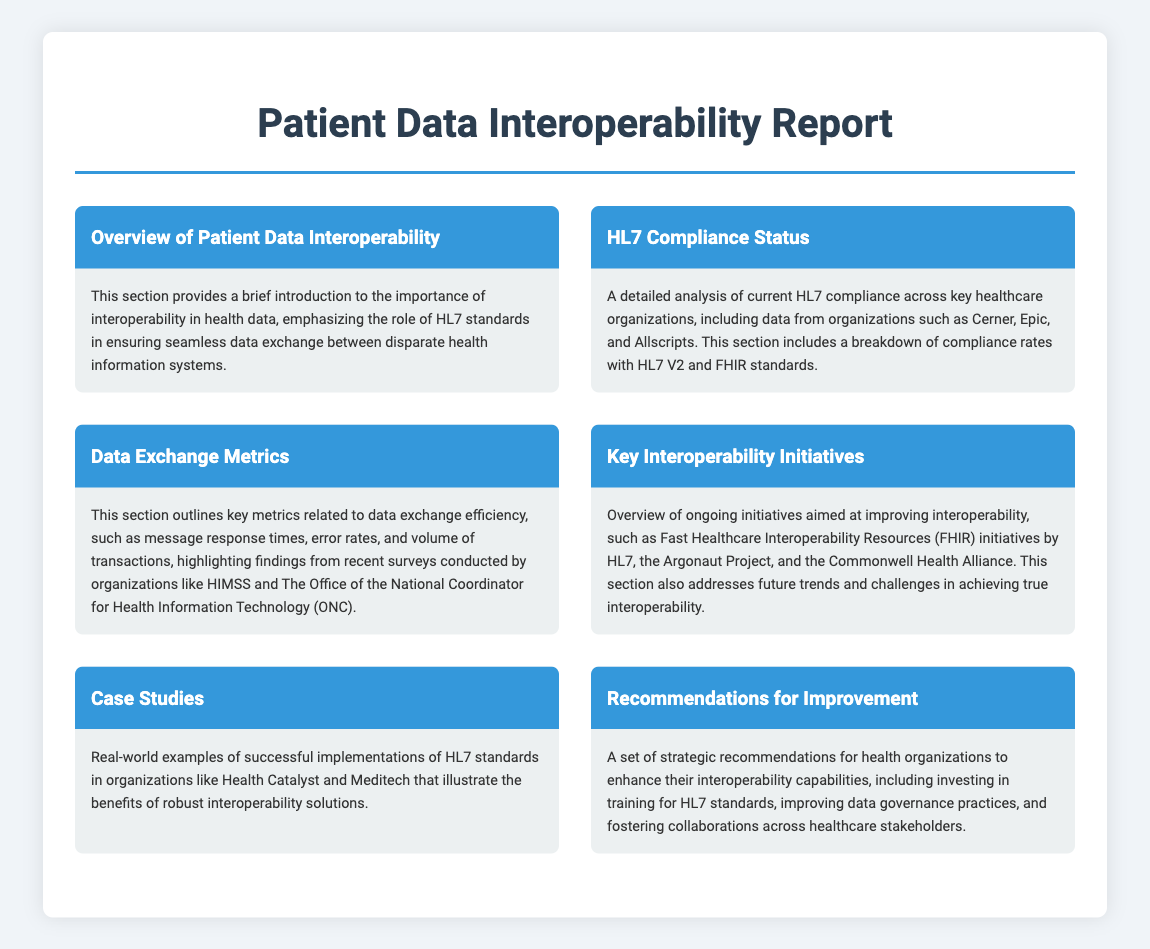what is the title of the report? The title is prominently displayed at the top of the document and summarizes the main focus of the content.
Answer: Patient Data Interoperability Report which section discusses HL7 compliance? The section titled "HL7 Compliance Status" specifically addresses compliance metrics related to HL7 standards.
Answer: HL7 Compliance Status what organizations are mentioned in the HL7 compliance section? The document lists key healthcare organizations that are analyzed for HL7 compliance, specifically within that section.
Answer: Cerner, Epic, Allscripts what kind of metrics are highlighted in the Data Exchange Metrics section? This section outlines specific metrics related to efficiency in data exchange, indicating its focus.
Answer: message response times, error rates, volume of transactions what is being discussed in the Key Interoperability Initiatives section? This section provides an overview of various ongoing initiatives aimed at improving interoperability in healthcare systems.
Answer: FHIR initiatives, Argonaut Project, Commonwell Health Alliance what is the purpose of the Recommendations for Improvement section? This section aims to provide strategic advice tailored for health organizations to enhance their interoperability capabilities.
Answer: enhance interoperability capabilities how many case studies are mentioned in the report? The document mentions one section specifically dedicated to case studies that provide real-world examples.
Answer: Case Studies what is emphasized as crucial for interoperability in the Overview of Patient Data Interoperability? This section highlights the foundational importance of a specific standard necessary for data exchange.
Answer: HL7 standards 